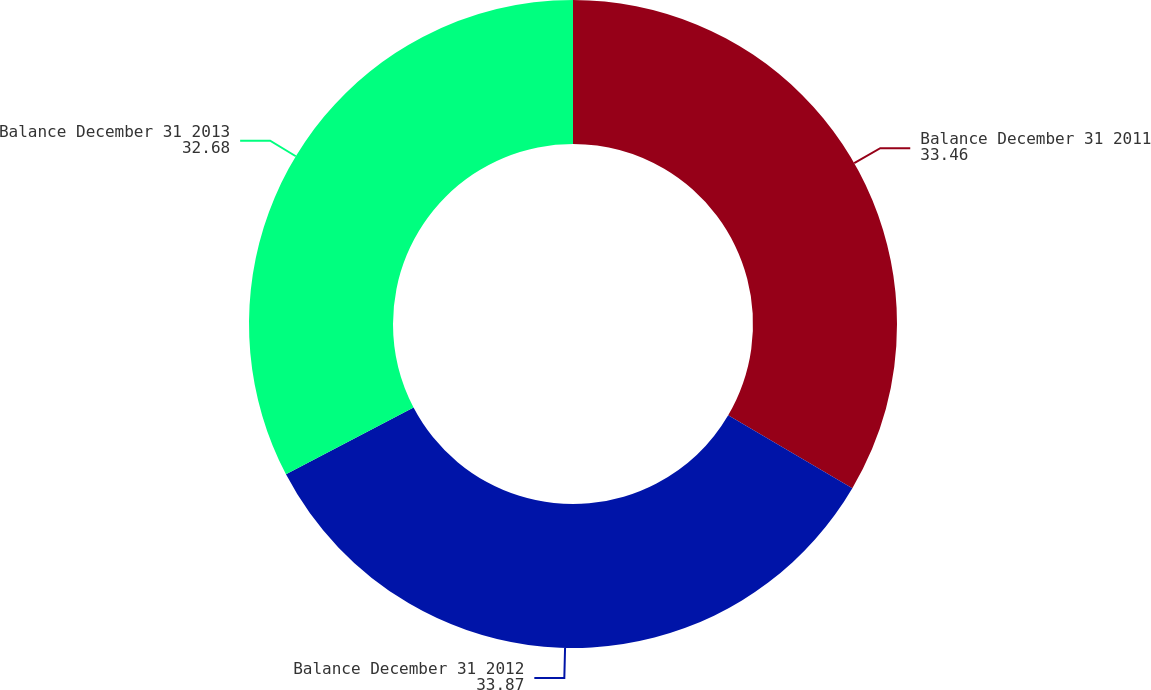Convert chart. <chart><loc_0><loc_0><loc_500><loc_500><pie_chart><fcel>Balance December 31 2011<fcel>Balance December 31 2012<fcel>Balance December 31 2013<nl><fcel>33.46%<fcel>33.87%<fcel>32.68%<nl></chart> 